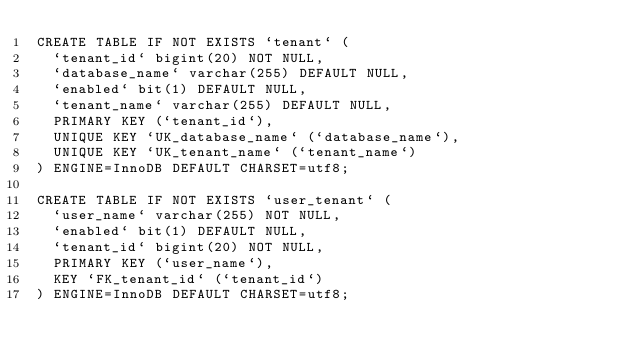<code> <loc_0><loc_0><loc_500><loc_500><_SQL_>CREATE TABLE IF NOT EXISTS `tenant` (
  `tenant_id` bigint(20) NOT NULL,
  `database_name` varchar(255) DEFAULT NULL,
  `enabled` bit(1) DEFAULT NULL,
  `tenant_name` varchar(255) DEFAULT NULL,
  PRIMARY KEY (`tenant_id`),
  UNIQUE KEY `UK_database_name` (`database_name`),
  UNIQUE KEY `UK_tenant_name` (`tenant_name`)
) ENGINE=InnoDB DEFAULT CHARSET=utf8;

CREATE TABLE IF NOT EXISTS `user_tenant` (
  `user_name` varchar(255) NOT NULL,
  `enabled` bit(1) DEFAULT NULL,
  `tenant_id` bigint(20) NOT NULL,
  PRIMARY KEY (`user_name`),
  KEY `FK_tenant_id` (`tenant_id`)
) ENGINE=InnoDB DEFAULT CHARSET=utf8;

</code> 